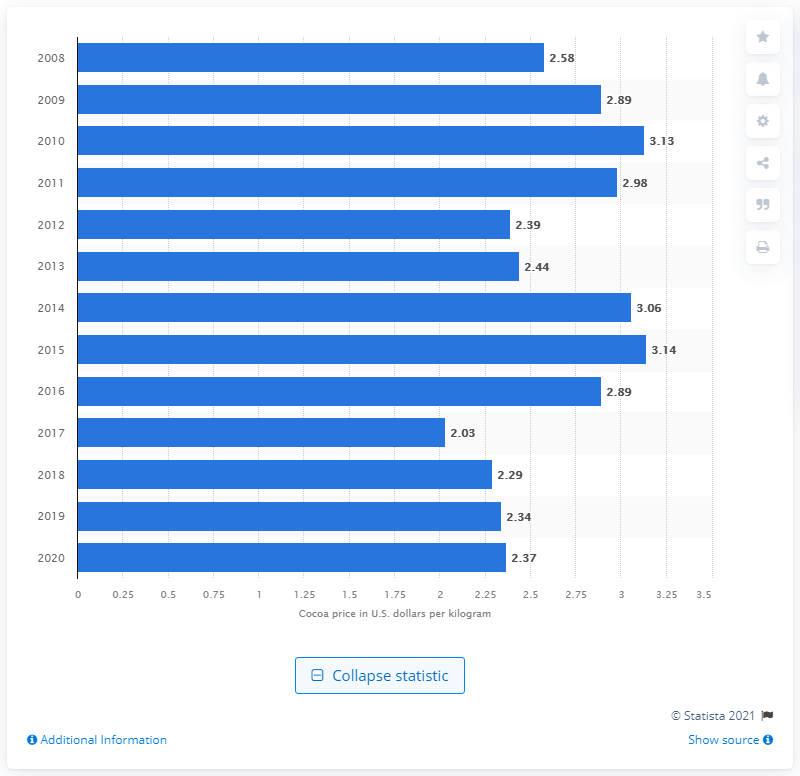Identify some key points in this picture. In 2020, the price per kilogram of cocoa in the United States was approximately 2.37 dollars. 